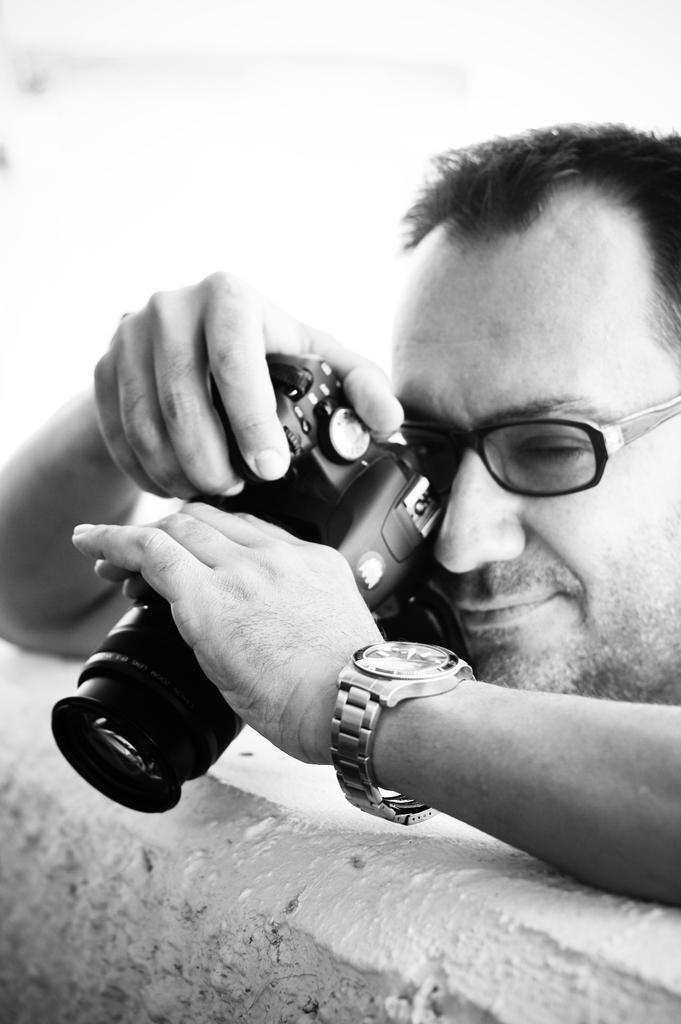Can you describe this image briefly? This is the black and white picture of a man taking pictures in the camera leaning on the wall. 